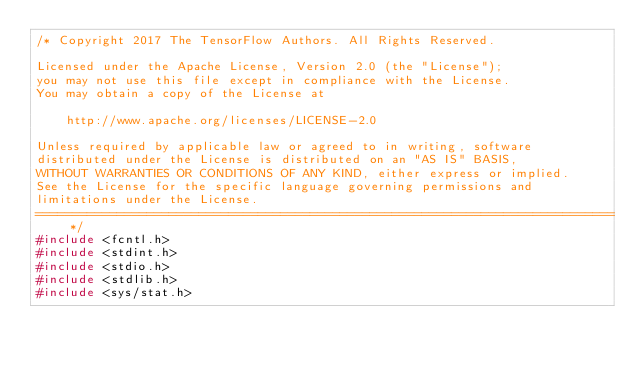<code> <loc_0><loc_0><loc_500><loc_500><_C++_>/* Copyright 2017 The TensorFlow Authors. All Rights Reserved.

Licensed under the Apache License, Version 2.0 (the "License");
you may not use this file except in compliance with the License.
You may obtain a copy of the License at

    http://www.apache.org/licenses/LICENSE-2.0

Unless required by applicable law or agreed to in writing, software
distributed under the License is distributed on an "AS IS" BASIS,
WITHOUT WARRANTIES OR CONDITIONS OF ANY KIND, either express or implied.
See the License for the specific language governing permissions and
limitations under the License.
==============================================================================*/
#include <fcntl.h>
#include <stdint.h>
#include <stdio.h>
#include <stdlib.h>
#include <sys/stat.h></code> 